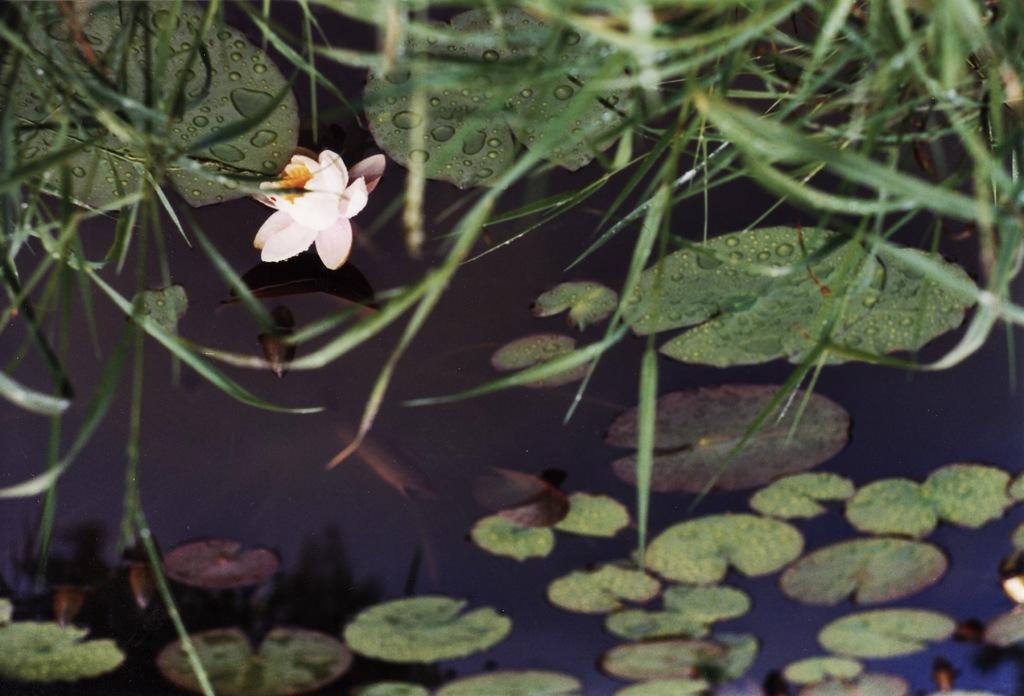In one or two sentences, can you explain what this image depicts? In this image I can see water, leaves, grass, flowers and plants. This image is taken may be during night. 